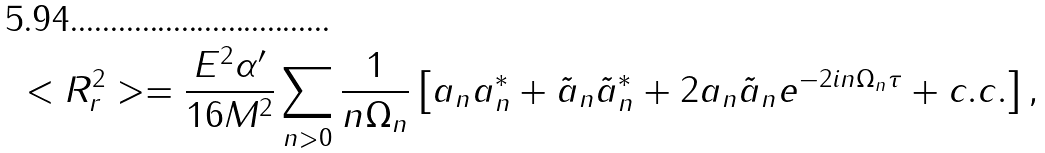Convert formula to latex. <formula><loc_0><loc_0><loc_500><loc_500>< R ^ { 2 } _ { r } > = \frac { E ^ { 2 } \alpha ^ { \prime } } { 1 6 M ^ { 2 } } \sum _ { n > 0 } \frac { 1 } { n \Omega _ { n } } \left [ a _ { n } a _ { n } ^ { * } + \tilde { a } _ { n } \tilde { a } _ { n } ^ { * } + 2 a _ { n } \tilde { a } _ { n } e ^ { - 2 i n \Omega _ { n } \tau } + c . c . \right ] ,</formula> 